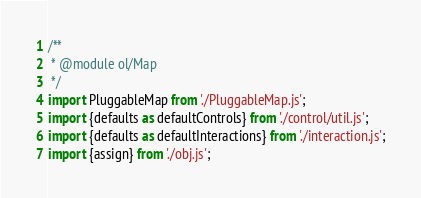Convert code to text. <code><loc_0><loc_0><loc_500><loc_500><_JavaScript_>/**
 * @module ol/Map
 */
import PluggableMap from './PluggableMap.js';
import {defaults as defaultControls} from './control/util.js';
import {defaults as defaultInteractions} from './interaction.js';
import {assign} from './obj.js';</code> 